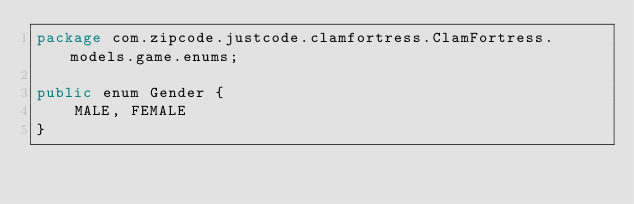Convert code to text. <code><loc_0><loc_0><loc_500><loc_500><_Java_>package com.zipcode.justcode.clamfortress.ClamFortress.models.game.enums;

public enum Gender {
    MALE, FEMALE
}
</code> 